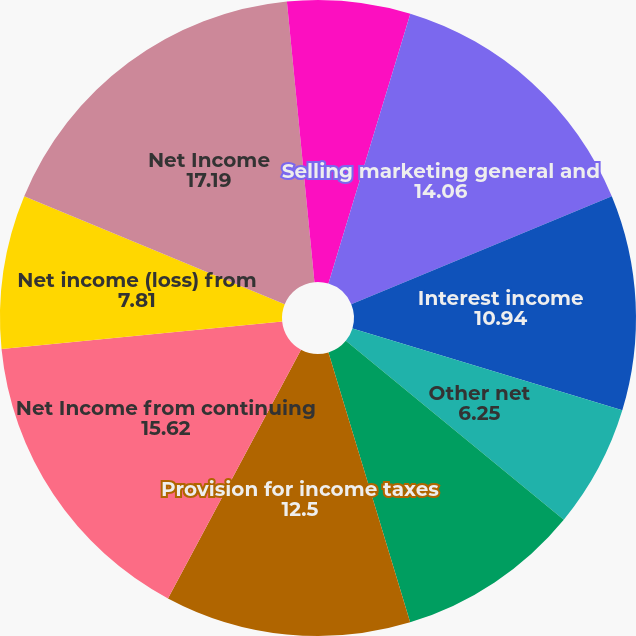<chart> <loc_0><loc_0><loc_500><loc_500><pie_chart><fcel>of Total Revenue<fcel>Selling marketing general and<fcel>Interest income<fcel>Other net<fcel>Total nonoperating (income)<fcel>Provision for income taxes<fcel>Net Income from continuing<fcel>Net income (loss) from<fcel>Net Income<fcel>Income from continuing<nl><fcel>4.69%<fcel>14.06%<fcel>10.94%<fcel>6.25%<fcel>9.38%<fcel>12.5%<fcel>15.62%<fcel>7.81%<fcel>17.19%<fcel>1.56%<nl></chart> 